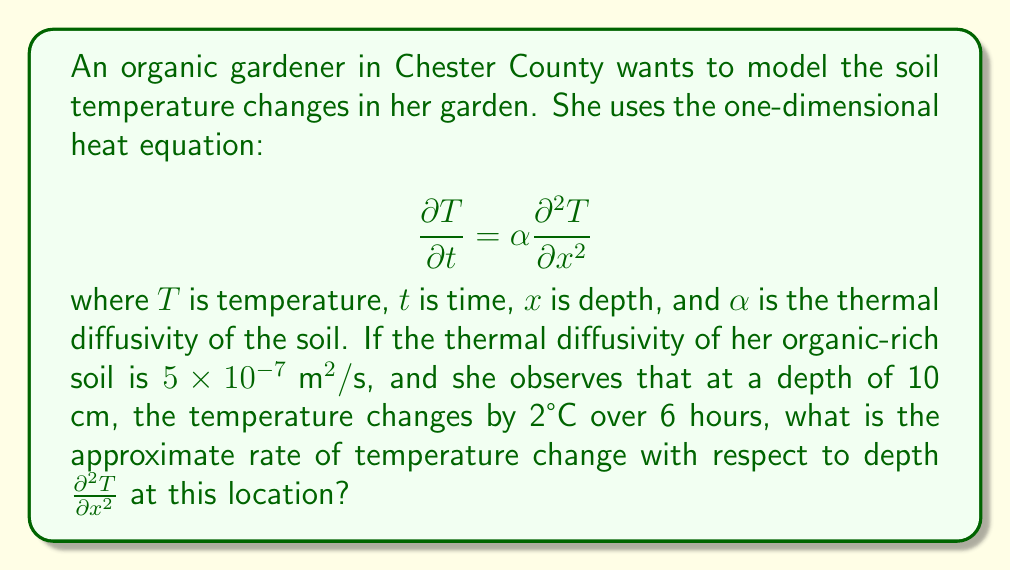Could you help me with this problem? Let's approach this step-by-step:

1) We are given the heat equation:
   $$\frac{\partial T}{\partial t} = \alpha \frac{\partial^2 T}{\partial x^2}$$

2) We know:
   - $\alpha = 5 \times 10^{-7} \text{ m}^2/\text{s}$
   - $\Delta T = 2°\text{C}$
   - $\Delta t = 6 \text{ hours} = 6 \times 3600 = 21600 \text{ seconds}$

3) We can approximate $\frac{\partial T}{\partial t}$ as $\frac{\Delta T}{\Delta t}$:
   $$\frac{\partial T}{\partial t} \approx \frac{\Delta T}{\Delta t} = \frac{2°\text{C}}{21600 \text{ s}} = 9.26 \times 10^{-5} °\text{C}/\text{s}$$

4) Now we can substitute this and the known $\alpha$ into the heat equation:
   $$9.26 \times 10^{-5} = (5 \times 10^{-7}) \frac{\partial^2 T}{\partial x^2}$$

5) Solving for $\frac{\partial^2 T}{\partial x^2}$:
   $$\frac{\partial^2 T}{\partial x^2} = \frac{9.26 \times 10^{-5}}{5 \times 10^{-7}} = 185.2 °\text{C}/\text{m}^2$$

Therefore, the rate of temperature change with respect to depth is approximately 185.2 °C/m².
Answer: 185.2 °C/m² 